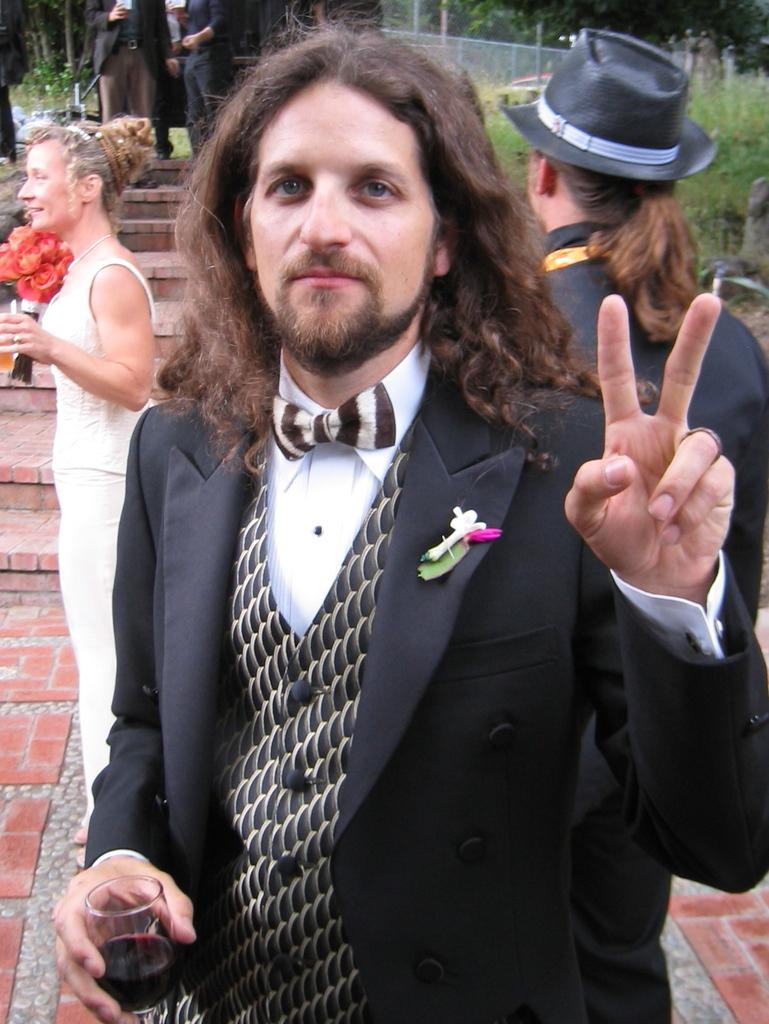How many people are in the image? There are people in the image. What is the person standing on the left holding? The person standing on the left is holding a flower bouquet. What can be seen in the background of the image? There are trees and a fence in the background of the image. Are there any architectural features in the image? Yes, there are stairs in the image. How many apples are on the front of the fence in the image? There are no apples present in the image, and the front of the fence is not mentioned in the provided facts. 